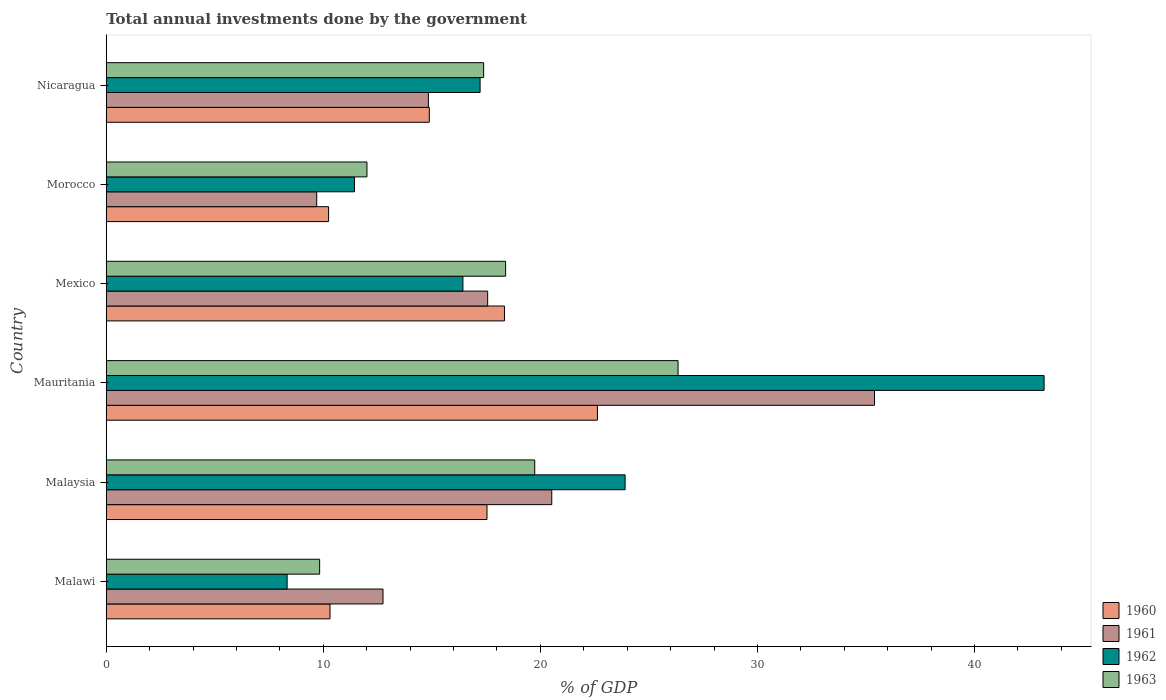How many different coloured bars are there?
Your answer should be very brief. 4. How many bars are there on the 4th tick from the bottom?
Provide a succinct answer. 4. What is the label of the 2nd group of bars from the top?
Offer a terse response. Morocco. In how many cases, is the number of bars for a given country not equal to the number of legend labels?
Offer a very short reply. 0. What is the total annual investments done by the government in 1962 in Mauritania?
Ensure brevity in your answer.  43.21. Across all countries, what is the maximum total annual investments done by the government in 1961?
Offer a very short reply. 35.39. Across all countries, what is the minimum total annual investments done by the government in 1961?
Your answer should be compact. 9.7. In which country was the total annual investments done by the government in 1961 maximum?
Offer a very short reply. Mauritania. In which country was the total annual investments done by the government in 1961 minimum?
Make the answer very short. Morocco. What is the total total annual investments done by the government in 1961 in the graph?
Ensure brevity in your answer.  110.78. What is the difference between the total annual investments done by the government in 1963 in Malaysia and that in Mexico?
Your answer should be very brief. 1.34. What is the difference between the total annual investments done by the government in 1963 in Mauritania and the total annual investments done by the government in 1961 in Mexico?
Your answer should be compact. 8.77. What is the average total annual investments done by the government in 1962 per country?
Provide a short and direct response. 20.09. What is the difference between the total annual investments done by the government in 1960 and total annual investments done by the government in 1963 in Mexico?
Your response must be concise. -0.05. In how many countries, is the total annual investments done by the government in 1961 greater than 28 %?
Your answer should be compact. 1. What is the ratio of the total annual investments done by the government in 1963 in Malaysia to that in Morocco?
Ensure brevity in your answer.  1.64. Is the total annual investments done by the government in 1961 in Mauritania less than that in Morocco?
Offer a terse response. No. What is the difference between the highest and the second highest total annual investments done by the government in 1962?
Offer a terse response. 19.3. What is the difference between the highest and the lowest total annual investments done by the government in 1961?
Offer a terse response. 25.7. In how many countries, is the total annual investments done by the government in 1960 greater than the average total annual investments done by the government in 1960 taken over all countries?
Provide a succinct answer. 3. What does the 2nd bar from the top in Malaysia represents?
Your response must be concise. 1962. What does the 3rd bar from the bottom in Nicaragua represents?
Keep it short and to the point. 1962. Is it the case that in every country, the sum of the total annual investments done by the government in 1963 and total annual investments done by the government in 1961 is greater than the total annual investments done by the government in 1962?
Offer a terse response. Yes. How many bars are there?
Your answer should be compact. 24. Are the values on the major ticks of X-axis written in scientific E-notation?
Offer a terse response. No. How many legend labels are there?
Keep it short and to the point. 4. What is the title of the graph?
Your response must be concise. Total annual investments done by the government. Does "1985" appear as one of the legend labels in the graph?
Your response must be concise. No. What is the label or title of the X-axis?
Provide a short and direct response. % of GDP. What is the label or title of the Y-axis?
Provide a short and direct response. Country. What is the % of GDP in 1960 in Malawi?
Offer a very short reply. 10.31. What is the % of GDP of 1961 in Malawi?
Your response must be concise. 12.75. What is the % of GDP of 1962 in Malawi?
Your response must be concise. 8.33. What is the % of GDP of 1963 in Malawi?
Give a very brief answer. 9.83. What is the % of GDP in 1960 in Malaysia?
Your answer should be compact. 17.54. What is the % of GDP of 1961 in Malaysia?
Offer a terse response. 20.52. What is the % of GDP of 1962 in Malaysia?
Provide a succinct answer. 23.9. What is the % of GDP in 1963 in Malaysia?
Provide a succinct answer. 19.74. What is the % of GDP in 1960 in Mauritania?
Your response must be concise. 22.63. What is the % of GDP of 1961 in Mauritania?
Your answer should be very brief. 35.39. What is the % of GDP of 1962 in Mauritania?
Offer a terse response. 43.21. What is the % of GDP of 1963 in Mauritania?
Keep it short and to the point. 26.34. What is the % of GDP in 1960 in Mexico?
Your response must be concise. 18.35. What is the % of GDP in 1961 in Mexico?
Make the answer very short. 17.57. What is the % of GDP in 1962 in Mexico?
Your answer should be very brief. 16.43. What is the % of GDP in 1963 in Mexico?
Your answer should be compact. 18.4. What is the % of GDP in 1960 in Morocco?
Provide a succinct answer. 10.24. What is the % of GDP of 1961 in Morocco?
Offer a terse response. 9.7. What is the % of GDP in 1962 in Morocco?
Offer a terse response. 11.43. What is the % of GDP in 1963 in Morocco?
Offer a very short reply. 12.01. What is the % of GDP of 1960 in Nicaragua?
Give a very brief answer. 14.88. What is the % of GDP in 1961 in Nicaragua?
Provide a succinct answer. 14.84. What is the % of GDP of 1962 in Nicaragua?
Your answer should be compact. 17.22. What is the % of GDP of 1963 in Nicaragua?
Your answer should be compact. 17.39. Across all countries, what is the maximum % of GDP of 1960?
Make the answer very short. 22.63. Across all countries, what is the maximum % of GDP in 1961?
Ensure brevity in your answer.  35.39. Across all countries, what is the maximum % of GDP in 1962?
Your answer should be compact. 43.21. Across all countries, what is the maximum % of GDP of 1963?
Your answer should be compact. 26.34. Across all countries, what is the minimum % of GDP of 1960?
Offer a very short reply. 10.24. Across all countries, what is the minimum % of GDP of 1961?
Provide a short and direct response. 9.7. Across all countries, what is the minimum % of GDP in 1962?
Keep it short and to the point. 8.33. Across all countries, what is the minimum % of GDP of 1963?
Your response must be concise. 9.83. What is the total % of GDP in 1960 in the graph?
Provide a succinct answer. 93.95. What is the total % of GDP of 1961 in the graph?
Ensure brevity in your answer.  110.78. What is the total % of GDP in 1962 in the graph?
Offer a very short reply. 120.53. What is the total % of GDP of 1963 in the graph?
Keep it short and to the point. 103.71. What is the difference between the % of GDP in 1960 in Malawi and that in Malaysia?
Keep it short and to the point. -7.23. What is the difference between the % of GDP in 1961 in Malawi and that in Malaysia?
Your answer should be very brief. -7.77. What is the difference between the % of GDP of 1962 in Malawi and that in Malaysia?
Your answer should be compact. -15.57. What is the difference between the % of GDP of 1963 in Malawi and that in Malaysia?
Provide a short and direct response. -9.91. What is the difference between the % of GDP of 1960 in Malawi and that in Mauritania?
Offer a very short reply. -12.32. What is the difference between the % of GDP of 1961 in Malawi and that in Mauritania?
Offer a very short reply. -22.64. What is the difference between the % of GDP of 1962 in Malawi and that in Mauritania?
Offer a terse response. -34.87. What is the difference between the % of GDP of 1963 in Malawi and that in Mauritania?
Offer a terse response. -16.51. What is the difference between the % of GDP of 1960 in Malawi and that in Mexico?
Offer a very short reply. -8.04. What is the difference between the % of GDP in 1961 in Malawi and that in Mexico?
Offer a very short reply. -4.82. What is the difference between the % of GDP in 1962 in Malawi and that in Mexico?
Offer a very short reply. -8.1. What is the difference between the % of GDP in 1963 in Malawi and that in Mexico?
Give a very brief answer. -8.57. What is the difference between the % of GDP in 1960 in Malawi and that in Morocco?
Ensure brevity in your answer.  0.07. What is the difference between the % of GDP of 1961 in Malawi and that in Morocco?
Provide a succinct answer. 3.06. What is the difference between the % of GDP in 1962 in Malawi and that in Morocco?
Keep it short and to the point. -3.1. What is the difference between the % of GDP in 1963 in Malawi and that in Morocco?
Make the answer very short. -2.18. What is the difference between the % of GDP in 1960 in Malawi and that in Nicaragua?
Provide a succinct answer. -4.57. What is the difference between the % of GDP of 1961 in Malawi and that in Nicaragua?
Ensure brevity in your answer.  -2.09. What is the difference between the % of GDP in 1962 in Malawi and that in Nicaragua?
Your answer should be very brief. -8.89. What is the difference between the % of GDP of 1963 in Malawi and that in Nicaragua?
Make the answer very short. -7.56. What is the difference between the % of GDP in 1960 in Malaysia and that in Mauritania?
Ensure brevity in your answer.  -5.09. What is the difference between the % of GDP of 1961 in Malaysia and that in Mauritania?
Provide a succinct answer. -14.87. What is the difference between the % of GDP in 1962 in Malaysia and that in Mauritania?
Your answer should be very brief. -19.3. What is the difference between the % of GDP in 1963 in Malaysia and that in Mauritania?
Provide a succinct answer. -6.6. What is the difference between the % of GDP of 1960 in Malaysia and that in Mexico?
Offer a terse response. -0.8. What is the difference between the % of GDP of 1961 in Malaysia and that in Mexico?
Offer a very short reply. 2.95. What is the difference between the % of GDP in 1962 in Malaysia and that in Mexico?
Your answer should be very brief. 7.47. What is the difference between the % of GDP of 1963 in Malaysia and that in Mexico?
Offer a terse response. 1.34. What is the difference between the % of GDP of 1960 in Malaysia and that in Morocco?
Make the answer very short. 7.3. What is the difference between the % of GDP of 1961 in Malaysia and that in Morocco?
Offer a terse response. 10.83. What is the difference between the % of GDP of 1962 in Malaysia and that in Morocco?
Give a very brief answer. 12.47. What is the difference between the % of GDP in 1963 in Malaysia and that in Morocco?
Your answer should be compact. 7.73. What is the difference between the % of GDP in 1960 in Malaysia and that in Nicaragua?
Offer a terse response. 2.66. What is the difference between the % of GDP of 1961 in Malaysia and that in Nicaragua?
Give a very brief answer. 5.68. What is the difference between the % of GDP of 1962 in Malaysia and that in Nicaragua?
Provide a succinct answer. 6.68. What is the difference between the % of GDP of 1963 in Malaysia and that in Nicaragua?
Keep it short and to the point. 2.35. What is the difference between the % of GDP of 1960 in Mauritania and that in Mexico?
Your response must be concise. 4.28. What is the difference between the % of GDP in 1961 in Mauritania and that in Mexico?
Your response must be concise. 17.82. What is the difference between the % of GDP of 1962 in Mauritania and that in Mexico?
Make the answer very short. 26.77. What is the difference between the % of GDP in 1963 in Mauritania and that in Mexico?
Your answer should be very brief. 7.94. What is the difference between the % of GDP in 1960 in Mauritania and that in Morocco?
Make the answer very short. 12.38. What is the difference between the % of GDP in 1961 in Mauritania and that in Morocco?
Offer a very short reply. 25.7. What is the difference between the % of GDP of 1962 in Mauritania and that in Morocco?
Ensure brevity in your answer.  31.77. What is the difference between the % of GDP in 1963 in Mauritania and that in Morocco?
Provide a succinct answer. 14.33. What is the difference between the % of GDP of 1960 in Mauritania and that in Nicaragua?
Keep it short and to the point. 7.74. What is the difference between the % of GDP of 1961 in Mauritania and that in Nicaragua?
Offer a very short reply. 20.55. What is the difference between the % of GDP in 1962 in Mauritania and that in Nicaragua?
Provide a succinct answer. 25.98. What is the difference between the % of GDP of 1963 in Mauritania and that in Nicaragua?
Provide a succinct answer. 8.96. What is the difference between the % of GDP of 1960 in Mexico and that in Morocco?
Make the answer very short. 8.1. What is the difference between the % of GDP in 1961 in Mexico and that in Morocco?
Provide a succinct answer. 7.88. What is the difference between the % of GDP of 1962 in Mexico and that in Morocco?
Your response must be concise. 5. What is the difference between the % of GDP of 1963 in Mexico and that in Morocco?
Ensure brevity in your answer.  6.39. What is the difference between the % of GDP of 1960 in Mexico and that in Nicaragua?
Ensure brevity in your answer.  3.46. What is the difference between the % of GDP of 1961 in Mexico and that in Nicaragua?
Give a very brief answer. 2.73. What is the difference between the % of GDP of 1962 in Mexico and that in Nicaragua?
Your answer should be very brief. -0.79. What is the difference between the % of GDP of 1963 in Mexico and that in Nicaragua?
Your answer should be very brief. 1.01. What is the difference between the % of GDP of 1960 in Morocco and that in Nicaragua?
Provide a short and direct response. -4.64. What is the difference between the % of GDP in 1961 in Morocco and that in Nicaragua?
Keep it short and to the point. -5.15. What is the difference between the % of GDP of 1962 in Morocco and that in Nicaragua?
Ensure brevity in your answer.  -5.79. What is the difference between the % of GDP of 1963 in Morocco and that in Nicaragua?
Provide a short and direct response. -5.38. What is the difference between the % of GDP of 1960 in Malawi and the % of GDP of 1961 in Malaysia?
Ensure brevity in your answer.  -10.22. What is the difference between the % of GDP in 1960 in Malawi and the % of GDP in 1962 in Malaysia?
Your answer should be compact. -13.59. What is the difference between the % of GDP of 1960 in Malawi and the % of GDP of 1963 in Malaysia?
Make the answer very short. -9.43. What is the difference between the % of GDP of 1961 in Malawi and the % of GDP of 1962 in Malaysia?
Give a very brief answer. -11.15. What is the difference between the % of GDP in 1961 in Malawi and the % of GDP in 1963 in Malaysia?
Give a very brief answer. -6.99. What is the difference between the % of GDP of 1962 in Malawi and the % of GDP of 1963 in Malaysia?
Keep it short and to the point. -11.41. What is the difference between the % of GDP of 1960 in Malawi and the % of GDP of 1961 in Mauritania?
Keep it short and to the point. -25.08. What is the difference between the % of GDP in 1960 in Malawi and the % of GDP in 1962 in Mauritania?
Offer a terse response. -32.9. What is the difference between the % of GDP of 1960 in Malawi and the % of GDP of 1963 in Mauritania?
Your answer should be compact. -16.03. What is the difference between the % of GDP in 1961 in Malawi and the % of GDP in 1962 in Mauritania?
Make the answer very short. -30.46. What is the difference between the % of GDP of 1961 in Malawi and the % of GDP of 1963 in Mauritania?
Provide a succinct answer. -13.59. What is the difference between the % of GDP of 1962 in Malawi and the % of GDP of 1963 in Mauritania?
Keep it short and to the point. -18.01. What is the difference between the % of GDP of 1960 in Malawi and the % of GDP of 1961 in Mexico?
Ensure brevity in your answer.  -7.26. What is the difference between the % of GDP in 1960 in Malawi and the % of GDP in 1962 in Mexico?
Your answer should be compact. -6.12. What is the difference between the % of GDP of 1960 in Malawi and the % of GDP of 1963 in Mexico?
Your answer should be very brief. -8.09. What is the difference between the % of GDP in 1961 in Malawi and the % of GDP in 1962 in Mexico?
Provide a short and direct response. -3.68. What is the difference between the % of GDP in 1961 in Malawi and the % of GDP in 1963 in Mexico?
Give a very brief answer. -5.65. What is the difference between the % of GDP of 1962 in Malawi and the % of GDP of 1963 in Mexico?
Offer a very short reply. -10.07. What is the difference between the % of GDP in 1960 in Malawi and the % of GDP in 1961 in Morocco?
Offer a very short reply. 0.61. What is the difference between the % of GDP in 1960 in Malawi and the % of GDP in 1962 in Morocco?
Make the answer very short. -1.13. What is the difference between the % of GDP in 1960 in Malawi and the % of GDP in 1963 in Morocco?
Your answer should be compact. -1.7. What is the difference between the % of GDP in 1961 in Malawi and the % of GDP in 1962 in Morocco?
Make the answer very short. 1.32. What is the difference between the % of GDP of 1961 in Malawi and the % of GDP of 1963 in Morocco?
Provide a short and direct response. 0.74. What is the difference between the % of GDP in 1962 in Malawi and the % of GDP in 1963 in Morocco?
Offer a terse response. -3.68. What is the difference between the % of GDP in 1960 in Malawi and the % of GDP in 1961 in Nicaragua?
Give a very brief answer. -4.53. What is the difference between the % of GDP of 1960 in Malawi and the % of GDP of 1962 in Nicaragua?
Offer a terse response. -6.91. What is the difference between the % of GDP of 1960 in Malawi and the % of GDP of 1963 in Nicaragua?
Provide a succinct answer. -7.08. What is the difference between the % of GDP in 1961 in Malawi and the % of GDP in 1962 in Nicaragua?
Give a very brief answer. -4.47. What is the difference between the % of GDP in 1961 in Malawi and the % of GDP in 1963 in Nicaragua?
Ensure brevity in your answer.  -4.64. What is the difference between the % of GDP of 1962 in Malawi and the % of GDP of 1963 in Nicaragua?
Offer a very short reply. -9.05. What is the difference between the % of GDP in 1960 in Malaysia and the % of GDP in 1961 in Mauritania?
Offer a very short reply. -17.85. What is the difference between the % of GDP of 1960 in Malaysia and the % of GDP of 1962 in Mauritania?
Offer a terse response. -25.67. What is the difference between the % of GDP in 1960 in Malaysia and the % of GDP in 1963 in Mauritania?
Your answer should be very brief. -8.8. What is the difference between the % of GDP in 1961 in Malaysia and the % of GDP in 1962 in Mauritania?
Your answer should be very brief. -22.68. What is the difference between the % of GDP of 1961 in Malaysia and the % of GDP of 1963 in Mauritania?
Offer a very short reply. -5.82. What is the difference between the % of GDP in 1962 in Malaysia and the % of GDP in 1963 in Mauritania?
Give a very brief answer. -2.44. What is the difference between the % of GDP in 1960 in Malaysia and the % of GDP in 1961 in Mexico?
Provide a succinct answer. -0.03. What is the difference between the % of GDP in 1960 in Malaysia and the % of GDP in 1962 in Mexico?
Offer a very short reply. 1.11. What is the difference between the % of GDP in 1960 in Malaysia and the % of GDP in 1963 in Mexico?
Keep it short and to the point. -0.86. What is the difference between the % of GDP of 1961 in Malaysia and the % of GDP of 1962 in Mexico?
Offer a very short reply. 4.09. What is the difference between the % of GDP of 1961 in Malaysia and the % of GDP of 1963 in Mexico?
Ensure brevity in your answer.  2.13. What is the difference between the % of GDP of 1962 in Malaysia and the % of GDP of 1963 in Mexico?
Provide a succinct answer. 5.5. What is the difference between the % of GDP of 1960 in Malaysia and the % of GDP of 1961 in Morocco?
Your response must be concise. 7.85. What is the difference between the % of GDP of 1960 in Malaysia and the % of GDP of 1962 in Morocco?
Provide a succinct answer. 6.11. What is the difference between the % of GDP of 1960 in Malaysia and the % of GDP of 1963 in Morocco?
Provide a succinct answer. 5.53. What is the difference between the % of GDP of 1961 in Malaysia and the % of GDP of 1962 in Morocco?
Your response must be concise. 9.09. What is the difference between the % of GDP of 1961 in Malaysia and the % of GDP of 1963 in Morocco?
Give a very brief answer. 8.51. What is the difference between the % of GDP in 1962 in Malaysia and the % of GDP in 1963 in Morocco?
Offer a terse response. 11.89. What is the difference between the % of GDP of 1960 in Malaysia and the % of GDP of 1961 in Nicaragua?
Your answer should be very brief. 2.7. What is the difference between the % of GDP in 1960 in Malaysia and the % of GDP in 1962 in Nicaragua?
Offer a very short reply. 0.32. What is the difference between the % of GDP in 1960 in Malaysia and the % of GDP in 1963 in Nicaragua?
Offer a very short reply. 0.15. What is the difference between the % of GDP in 1961 in Malaysia and the % of GDP in 1962 in Nicaragua?
Make the answer very short. 3.3. What is the difference between the % of GDP in 1961 in Malaysia and the % of GDP in 1963 in Nicaragua?
Ensure brevity in your answer.  3.14. What is the difference between the % of GDP in 1962 in Malaysia and the % of GDP in 1963 in Nicaragua?
Provide a succinct answer. 6.52. What is the difference between the % of GDP in 1960 in Mauritania and the % of GDP in 1961 in Mexico?
Offer a terse response. 5.06. What is the difference between the % of GDP in 1960 in Mauritania and the % of GDP in 1962 in Mexico?
Offer a terse response. 6.2. What is the difference between the % of GDP of 1960 in Mauritania and the % of GDP of 1963 in Mexico?
Give a very brief answer. 4.23. What is the difference between the % of GDP in 1961 in Mauritania and the % of GDP in 1962 in Mexico?
Your answer should be compact. 18.96. What is the difference between the % of GDP in 1961 in Mauritania and the % of GDP in 1963 in Mexico?
Provide a succinct answer. 16.99. What is the difference between the % of GDP of 1962 in Mauritania and the % of GDP of 1963 in Mexico?
Keep it short and to the point. 24.81. What is the difference between the % of GDP of 1960 in Mauritania and the % of GDP of 1961 in Morocco?
Give a very brief answer. 12.93. What is the difference between the % of GDP of 1960 in Mauritania and the % of GDP of 1962 in Morocco?
Make the answer very short. 11.19. What is the difference between the % of GDP of 1960 in Mauritania and the % of GDP of 1963 in Morocco?
Your answer should be compact. 10.62. What is the difference between the % of GDP in 1961 in Mauritania and the % of GDP in 1962 in Morocco?
Provide a succinct answer. 23.96. What is the difference between the % of GDP in 1961 in Mauritania and the % of GDP in 1963 in Morocco?
Offer a terse response. 23.38. What is the difference between the % of GDP of 1962 in Mauritania and the % of GDP of 1963 in Morocco?
Make the answer very short. 31.2. What is the difference between the % of GDP in 1960 in Mauritania and the % of GDP in 1961 in Nicaragua?
Offer a very short reply. 7.79. What is the difference between the % of GDP in 1960 in Mauritania and the % of GDP in 1962 in Nicaragua?
Keep it short and to the point. 5.4. What is the difference between the % of GDP of 1960 in Mauritania and the % of GDP of 1963 in Nicaragua?
Provide a succinct answer. 5.24. What is the difference between the % of GDP in 1961 in Mauritania and the % of GDP in 1962 in Nicaragua?
Give a very brief answer. 18.17. What is the difference between the % of GDP of 1961 in Mauritania and the % of GDP of 1963 in Nicaragua?
Make the answer very short. 18.01. What is the difference between the % of GDP of 1962 in Mauritania and the % of GDP of 1963 in Nicaragua?
Offer a very short reply. 25.82. What is the difference between the % of GDP in 1960 in Mexico and the % of GDP in 1961 in Morocco?
Your answer should be very brief. 8.65. What is the difference between the % of GDP of 1960 in Mexico and the % of GDP of 1962 in Morocco?
Offer a terse response. 6.91. What is the difference between the % of GDP in 1960 in Mexico and the % of GDP in 1963 in Morocco?
Keep it short and to the point. 6.34. What is the difference between the % of GDP in 1961 in Mexico and the % of GDP in 1962 in Morocco?
Ensure brevity in your answer.  6.14. What is the difference between the % of GDP of 1961 in Mexico and the % of GDP of 1963 in Morocco?
Offer a terse response. 5.56. What is the difference between the % of GDP of 1962 in Mexico and the % of GDP of 1963 in Morocco?
Your answer should be very brief. 4.42. What is the difference between the % of GDP in 1960 in Mexico and the % of GDP in 1961 in Nicaragua?
Provide a short and direct response. 3.5. What is the difference between the % of GDP in 1960 in Mexico and the % of GDP in 1962 in Nicaragua?
Provide a short and direct response. 1.12. What is the difference between the % of GDP of 1960 in Mexico and the % of GDP of 1963 in Nicaragua?
Offer a terse response. 0.96. What is the difference between the % of GDP of 1961 in Mexico and the % of GDP of 1962 in Nicaragua?
Offer a very short reply. 0.35. What is the difference between the % of GDP of 1961 in Mexico and the % of GDP of 1963 in Nicaragua?
Your response must be concise. 0.18. What is the difference between the % of GDP in 1962 in Mexico and the % of GDP in 1963 in Nicaragua?
Give a very brief answer. -0.95. What is the difference between the % of GDP of 1960 in Morocco and the % of GDP of 1961 in Nicaragua?
Offer a terse response. -4.6. What is the difference between the % of GDP in 1960 in Morocco and the % of GDP in 1962 in Nicaragua?
Make the answer very short. -6.98. What is the difference between the % of GDP in 1960 in Morocco and the % of GDP in 1963 in Nicaragua?
Keep it short and to the point. -7.14. What is the difference between the % of GDP of 1961 in Morocco and the % of GDP of 1962 in Nicaragua?
Your answer should be compact. -7.53. What is the difference between the % of GDP of 1961 in Morocco and the % of GDP of 1963 in Nicaragua?
Keep it short and to the point. -7.69. What is the difference between the % of GDP in 1962 in Morocco and the % of GDP in 1963 in Nicaragua?
Keep it short and to the point. -5.95. What is the average % of GDP in 1960 per country?
Your answer should be very brief. 15.66. What is the average % of GDP in 1961 per country?
Give a very brief answer. 18.46. What is the average % of GDP in 1962 per country?
Offer a terse response. 20.09. What is the average % of GDP in 1963 per country?
Make the answer very short. 17.29. What is the difference between the % of GDP of 1960 and % of GDP of 1961 in Malawi?
Give a very brief answer. -2.44. What is the difference between the % of GDP in 1960 and % of GDP in 1962 in Malawi?
Offer a terse response. 1.98. What is the difference between the % of GDP in 1960 and % of GDP in 1963 in Malawi?
Your answer should be very brief. 0.48. What is the difference between the % of GDP of 1961 and % of GDP of 1962 in Malawi?
Provide a short and direct response. 4.42. What is the difference between the % of GDP of 1961 and % of GDP of 1963 in Malawi?
Offer a terse response. 2.92. What is the difference between the % of GDP in 1962 and % of GDP in 1963 in Malawi?
Provide a short and direct response. -1.5. What is the difference between the % of GDP in 1960 and % of GDP in 1961 in Malaysia?
Give a very brief answer. -2.98. What is the difference between the % of GDP of 1960 and % of GDP of 1962 in Malaysia?
Give a very brief answer. -6.36. What is the difference between the % of GDP in 1960 and % of GDP in 1963 in Malaysia?
Provide a short and direct response. -2.2. What is the difference between the % of GDP in 1961 and % of GDP in 1962 in Malaysia?
Offer a very short reply. -3.38. What is the difference between the % of GDP in 1961 and % of GDP in 1963 in Malaysia?
Offer a terse response. 0.78. What is the difference between the % of GDP in 1962 and % of GDP in 1963 in Malaysia?
Keep it short and to the point. 4.16. What is the difference between the % of GDP in 1960 and % of GDP in 1961 in Mauritania?
Offer a terse response. -12.77. What is the difference between the % of GDP in 1960 and % of GDP in 1962 in Mauritania?
Give a very brief answer. -20.58. What is the difference between the % of GDP in 1960 and % of GDP in 1963 in Mauritania?
Your response must be concise. -3.72. What is the difference between the % of GDP in 1961 and % of GDP in 1962 in Mauritania?
Offer a terse response. -7.81. What is the difference between the % of GDP of 1961 and % of GDP of 1963 in Mauritania?
Keep it short and to the point. 9.05. What is the difference between the % of GDP of 1962 and % of GDP of 1963 in Mauritania?
Make the answer very short. 16.86. What is the difference between the % of GDP of 1960 and % of GDP of 1961 in Mexico?
Provide a short and direct response. 0.77. What is the difference between the % of GDP of 1960 and % of GDP of 1962 in Mexico?
Provide a short and direct response. 1.91. What is the difference between the % of GDP of 1960 and % of GDP of 1963 in Mexico?
Your response must be concise. -0.05. What is the difference between the % of GDP of 1961 and % of GDP of 1962 in Mexico?
Make the answer very short. 1.14. What is the difference between the % of GDP of 1961 and % of GDP of 1963 in Mexico?
Your answer should be very brief. -0.83. What is the difference between the % of GDP of 1962 and % of GDP of 1963 in Mexico?
Offer a very short reply. -1.97. What is the difference between the % of GDP in 1960 and % of GDP in 1961 in Morocco?
Make the answer very short. 0.55. What is the difference between the % of GDP in 1960 and % of GDP in 1962 in Morocco?
Make the answer very short. -1.19. What is the difference between the % of GDP in 1960 and % of GDP in 1963 in Morocco?
Your response must be concise. -1.77. What is the difference between the % of GDP in 1961 and % of GDP in 1962 in Morocco?
Offer a terse response. -1.74. What is the difference between the % of GDP of 1961 and % of GDP of 1963 in Morocco?
Keep it short and to the point. -2.32. What is the difference between the % of GDP of 1962 and % of GDP of 1963 in Morocco?
Keep it short and to the point. -0.58. What is the difference between the % of GDP in 1960 and % of GDP in 1961 in Nicaragua?
Your response must be concise. 0.04. What is the difference between the % of GDP of 1960 and % of GDP of 1962 in Nicaragua?
Provide a succinct answer. -2.34. What is the difference between the % of GDP in 1960 and % of GDP in 1963 in Nicaragua?
Your response must be concise. -2.5. What is the difference between the % of GDP in 1961 and % of GDP in 1962 in Nicaragua?
Provide a succinct answer. -2.38. What is the difference between the % of GDP in 1961 and % of GDP in 1963 in Nicaragua?
Offer a terse response. -2.55. What is the difference between the % of GDP of 1962 and % of GDP of 1963 in Nicaragua?
Provide a succinct answer. -0.16. What is the ratio of the % of GDP of 1960 in Malawi to that in Malaysia?
Offer a terse response. 0.59. What is the ratio of the % of GDP in 1961 in Malawi to that in Malaysia?
Keep it short and to the point. 0.62. What is the ratio of the % of GDP in 1962 in Malawi to that in Malaysia?
Your answer should be very brief. 0.35. What is the ratio of the % of GDP in 1963 in Malawi to that in Malaysia?
Your response must be concise. 0.5. What is the ratio of the % of GDP of 1960 in Malawi to that in Mauritania?
Offer a very short reply. 0.46. What is the ratio of the % of GDP of 1961 in Malawi to that in Mauritania?
Your response must be concise. 0.36. What is the ratio of the % of GDP in 1962 in Malawi to that in Mauritania?
Provide a succinct answer. 0.19. What is the ratio of the % of GDP of 1963 in Malawi to that in Mauritania?
Your response must be concise. 0.37. What is the ratio of the % of GDP of 1960 in Malawi to that in Mexico?
Ensure brevity in your answer.  0.56. What is the ratio of the % of GDP of 1961 in Malawi to that in Mexico?
Your response must be concise. 0.73. What is the ratio of the % of GDP in 1962 in Malawi to that in Mexico?
Make the answer very short. 0.51. What is the ratio of the % of GDP in 1963 in Malawi to that in Mexico?
Give a very brief answer. 0.53. What is the ratio of the % of GDP of 1960 in Malawi to that in Morocco?
Keep it short and to the point. 1.01. What is the ratio of the % of GDP of 1961 in Malawi to that in Morocco?
Your answer should be very brief. 1.32. What is the ratio of the % of GDP in 1962 in Malawi to that in Morocco?
Provide a succinct answer. 0.73. What is the ratio of the % of GDP of 1963 in Malawi to that in Morocco?
Offer a very short reply. 0.82. What is the ratio of the % of GDP of 1960 in Malawi to that in Nicaragua?
Ensure brevity in your answer.  0.69. What is the ratio of the % of GDP of 1961 in Malawi to that in Nicaragua?
Your answer should be very brief. 0.86. What is the ratio of the % of GDP of 1962 in Malawi to that in Nicaragua?
Make the answer very short. 0.48. What is the ratio of the % of GDP of 1963 in Malawi to that in Nicaragua?
Your answer should be very brief. 0.57. What is the ratio of the % of GDP in 1960 in Malaysia to that in Mauritania?
Offer a very short reply. 0.78. What is the ratio of the % of GDP in 1961 in Malaysia to that in Mauritania?
Keep it short and to the point. 0.58. What is the ratio of the % of GDP of 1962 in Malaysia to that in Mauritania?
Provide a succinct answer. 0.55. What is the ratio of the % of GDP in 1963 in Malaysia to that in Mauritania?
Offer a very short reply. 0.75. What is the ratio of the % of GDP in 1960 in Malaysia to that in Mexico?
Give a very brief answer. 0.96. What is the ratio of the % of GDP of 1961 in Malaysia to that in Mexico?
Your answer should be compact. 1.17. What is the ratio of the % of GDP in 1962 in Malaysia to that in Mexico?
Make the answer very short. 1.45. What is the ratio of the % of GDP in 1963 in Malaysia to that in Mexico?
Your answer should be compact. 1.07. What is the ratio of the % of GDP in 1960 in Malaysia to that in Morocco?
Make the answer very short. 1.71. What is the ratio of the % of GDP in 1961 in Malaysia to that in Morocco?
Give a very brief answer. 2.12. What is the ratio of the % of GDP of 1962 in Malaysia to that in Morocco?
Your answer should be very brief. 2.09. What is the ratio of the % of GDP in 1963 in Malaysia to that in Morocco?
Offer a terse response. 1.64. What is the ratio of the % of GDP of 1960 in Malaysia to that in Nicaragua?
Provide a succinct answer. 1.18. What is the ratio of the % of GDP in 1961 in Malaysia to that in Nicaragua?
Ensure brevity in your answer.  1.38. What is the ratio of the % of GDP in 1962 in Malaysia to that in Nicaragua?
Ensure brevity in your answer.  1.39. What is the ratio of the % of GDP in 1963 in Malaysia to that in Nicaragua?
Provide a succinct answer. 1.14. What is the ratio of the % of GDP of 1960 in Mauritania to that in Mexico?
Provide a short and direct response. 1.23. What is the ratio of the % of GDP of 1961 in Mauritania to that in Mexico?
Provide a succinct answer. 2.01. What is the ratio of the % of GDP of 1962 in Mauritania to that in Mexico?
Your answer should be very brief. 2.63. What is the ratio of the % of GDP of 1963 in Mauritania to that in Mexico?
Your answer should be compact. 1.43. What is the ratio of the % of GDP of 1960 in Mauritania to that in Morocco?
Make the answer very short. 2.21. What is the ratio of the % of GDP in 1961 in Mauritania to that in Morocco?
Your answer should be compact. 3.65. What is the ratio of the % of GDP in 1962 in Mauritania to that in Morocco?
Your answer should be compact. 3.78. What is the ratio of the % of GDP in 1963 in Mauritania to that in Morocco?
Your answer should be compact. 2.19. What is the ratio of the % of GDP in 1960 in Mauritania to that in Nicaragua?
Provide a succinct answer. 1.52. What is the ratio of the % of GDP of 1961 in Mauritania to that in Nicaragua?
Ensure brevity in your answer.  2.38. What is the ratio of the % of GDP of 1962 in Mauritania to that in Nicaragua?
Provide a short and direct response. 2.51. What is the ratio of the % of GDP in 1963 in Mauritania to that in Nicaragua?
Offer a terse response. 1.52. What is the ratio of the % of GDP of 1960 in Mexico to that in Morocco?
Make the answer very short. 1.79. What is the ratio of the % of GDP in 1961 in Mexico to that in Morocco?
Your answer should be very brief. 1.81. What is the ratio of the % of GDP of 1962 in Mexico to that in Morocco?
Offer a terse response. 1.44. What is the ratio of the % of GDP of 1963 in Mexico to that in Morocco?
Your answer should be very brief. 1.53. What is the ratio of the % of GDP in 1960 in Mexico to that in Nicaragua?
Your answer should be compact. 1.23. What is the ratio of the % of GDP in 1961 in Mexico to that in Nicaragua?
Ensure brevity in your answer.  1.18. What is the ratio of the % of GDP of 1962 in Mexico to that in Nicaragua?
Offer a terse response. 0.95. What is the ratio of the % of GDP of 1963 in Mexico to that in Nicaragua?
Give a very brief answer. 1.06. What is the ratio of the % of GDP in 1960 in Morocco to that in Nicaragua?
Your answer should be very brief. 0.69. What is the ratio of the % of GDP of 1961 in Morocco to that in Nicaragua?
Make the answer very short. 0.65. What is the ratio of the % of GDP in 1962 in Morocco to that in Nicaragua?
Give a very brief answer. 0.66. What is the ratio of the % of GDP in 1963 in Morocco to that in Nicaragua?
Your answer should be compact. 0.69. What is the difference between the highest and the second highest % of GDP of 1960?
Keep it short and to the point. 4.28. What is the difference between the highest and the second highest % of GDP of 1961?
Provide a succinct answer. 14.87. What is the difference between the highest and the second highest % of GDP in 1962?
Keep it short and to the point. 19.3. What is the difference between the highest and the second highest % of GDP of 1963?
Your answer should be very brief. 6.6. What is the difference between the highest and the lowest % of GDP of 1960?
Your answer should be compact. 12.38. What is the difference between the highest and the lowest % of GDP in 1961?
Your answer should be compact. 25.7. What is the difference between the highest and the lowest % of GDP of 1962?
Ensure brevity in your answer.  34.87. What is the difference between the highest and the lowest % of GDP of 1963?
Make the answer very short. 16.51. 